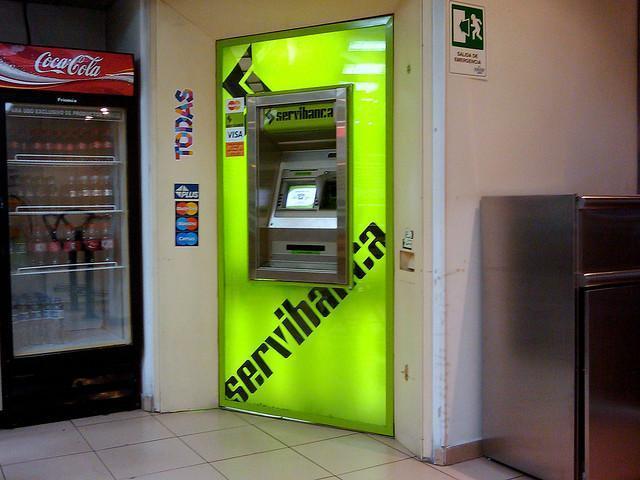How many shelves are in the fridge?
Give a very brief answer. 4. How many refrigerators are in the picture?
Give a very brief answer. 2. How many people on the beach?
Give a very brief answer. 0. 